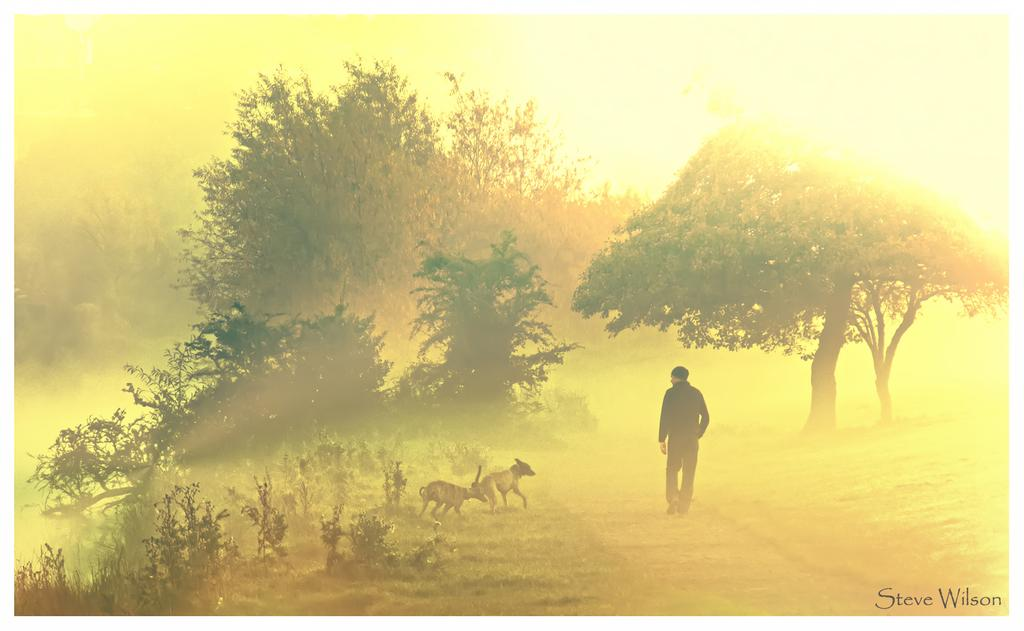What type of artwork is depicted in the image? The image is a painting. What is the person in the painting doing? There is a person walking in the painting. What other living beings are present in the painting? There are animals in the painting. What can be seen in the background of the painting? There are trees in the background of the painting. What type of protest is taking place in the painting? There is no protest depicted in the painting; it features a person walking and animals in a setting with trees in the background. 